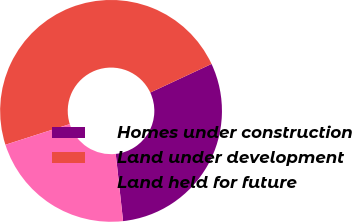Convert chart to OTSL. <chart><loc_0><loc_0><loc_500><loc_500><pie_chart><fcel>Homes under construction<fcel>Land under development<fcel>Land held for future<nl><fcel>30.22%<fcel>47.99%<fcel>21.79%<nl></chart> 